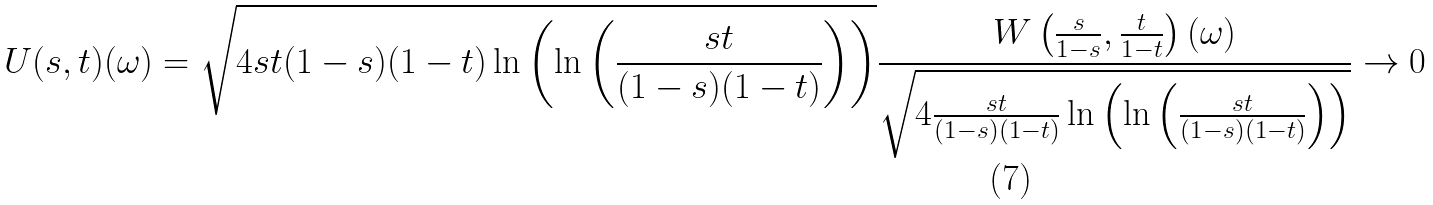Convert formula to latex. <formula><loc_0><loc_0><loc_500><loc_500>U ( s , t ) ( \omega ) = \sqrt { 4 s t ( 1 - s ) ( 1 - t ) \ln \left ( \ln \left ( \frac { s t } { ( 1 - s ) ( 1 - t ) } \right ) \right ) } \frac { W \left ( \frac { s } { 1 - s } , \frac { t } { 1 - t } \right ) ( \omega ) } { \sqrt { 4 \frac { s t } { ( 1 - s ) ( 1 - t ) } \ln \left ( \ln \left ( \frac { s t } { ( 1 - s ) ( 1 - t ) } \right ) \right ) } } \to 0</formula> 